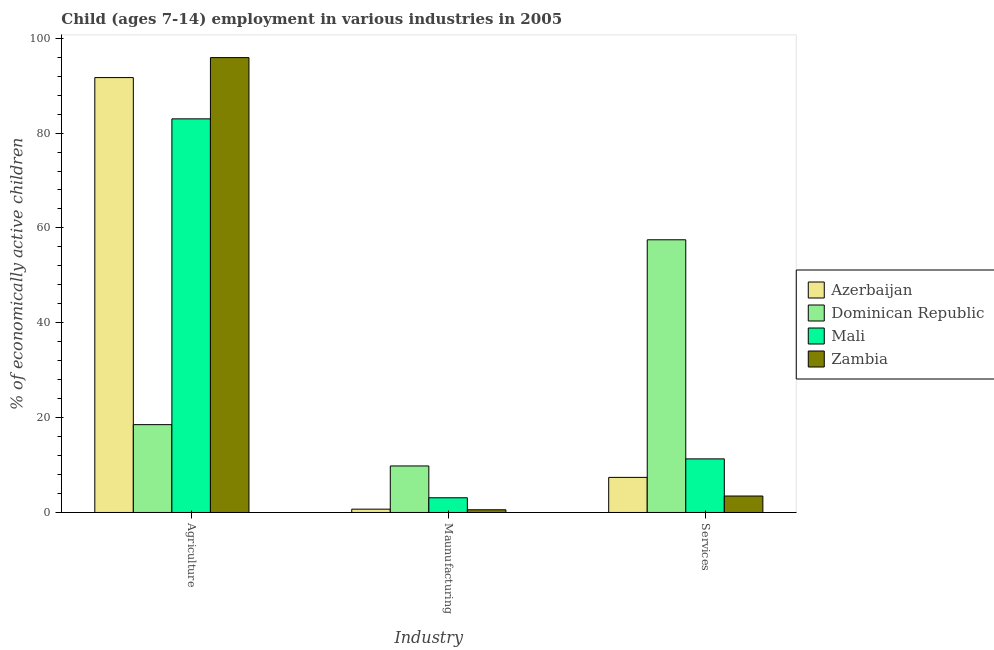How many different coloured bars are there?
Your response must be concise. 4. Are the number of bars per tick equal to the number of legend labels?
Offer a very short reply. Yes. How many bars are there on the 2nd tick from the left?
Ensure brevity in your answer.  4. What is the label of the 3rd group of bars from the left?
Provide a short and direct response. Services. What is the percentage of economically active children in manufacturing in Azerbaijan?
Offer a terse response. 0.7. Across all countries, what is the maximum percentage of economically active children in services?
Give a very brief answer. 57.5. Across all countries, what is the minimum percentage of economically active children in services?
Offer a terse response. 3.47. In which country was the percentage of economically active children in services maximum?
Offer a very short reply. Dominican Republic. In which country was the percentage of economically active children in manufacturing minimum?
Ensure brevity in your answer.  Zambia. What is the total percentage of economically active children in services in the graph?
Offer a very short reply. 79.67. What is the difference between the percentage of economically active children in agriculture in Dominican Republic and that in Zambia?
Give a very brief answer. -77.39. What is the difference between the percentage of economically active children in services in Azerbaijan and the percentage of economically active children in manufacturing in Zambia?
Ensure brevity in your answer.  6.83. What is the average percentage of economically active children in manufacturing per country?
Your response must be concise. 3.54. What is the ratio of the percentage of economically active children in services in Mali to that in Zambia?
Give a very brief answer. 3.26. Is the percentage of economically active children in manufacturing in Zambia less than that in Mali?
Offer a very short reply. Yes. What is the difference between the highest and the second highest percentage of economically active children in agriculture?
Provide a short and direct response. 4.21. What is the difference between the highest and the lowest percentage of economically active children in services?
Offer a terse response. 54.03. In how many countries, is the percentage of economically active children in services greater than the average percentage of economically active children in services taken over all countries?
Make the answer very short. 1. What does the 4th bar from the left in Services represents?
Ensure brevity in your answer.  Zambia. What does the 2nd bar from the right in Services represents?
Offer a very short reply. Mali. How many bars are there?
Provide a succinct answer. 12. Are the values on the major ticks of Y-axis written in scientific E-notation?
Give a very brief answer. No. Does the graph contain grids?
Provide a short and direct response. No. How are the legend labels stacked?
Your answer should be compact. Vertical. What is the title of the graph?
Your answer should be very brief. Child (ages 7-14) employment in various industries in 2005. Does "India" appear as one of the legend labels in the graph?
Ensure brevity in your answer.  No. What is the label or title of the X-axis?
Offer a terse response. Industry. What is the label or title of the Y-axis?
Ensure brevity in your answer.  % of economically active children. What is the % of economically active children in Azerbaijan in Agriculture?
Offer a very short reply. 91.7. What is the % of economically active children in Dominican Republic in Agriculture?
Ensure brevity in your answer.  18.52. What is the % of economically active children of Zambia in Agriculture?
Your answer should be compact. 95.91. What is the % of economically active children of Azerbaijan in Maunufacturing?
Offer a very short reply. 0.7. What is the % of economically active children of Dominican Republic in Maunufacturing?
Offer a terse response. 9.81. What is the % of economically active children in Mali in Maunufacturing?
Keep it short and to the point. 3.1. What is the % of economically active children in Zambia in Maunufacturing?
Provide a succinct answer. 0.57. What is the % of economically active children in Azerbaijan in Services?
Offer a very short reply. 7.4. What is the % of economically active children in Dominican Republic in Services?
Offer a very short reply. 57.5. What is the % of economically active children in Zambia in Services?
Provide a succinct answer. 3.47. Across all Industry, what is the maximum % of economically active children in Azerbaijan?
Give a very brief answer. 91.7. Across all Industry, what is the maximum % of economically active children in Dominican Republic?
Keep it short and to the point. 57.5. Across all Industry, what is the maximum % of economically active children of Mali?
Provide a succinct answer. 83. Across all Industry, what is the maximum % of economically active children in Zambia?
Keep it short and to the point. 95.91. Across all Industry, what is the minimum % of economically active children of Azerbaijan?
Make the answer very short. 0.7. Across all Industry, what is the minimum % of economically active children in Dominican Republic?
Provide a short and direct response. 9.81. Across all Industry, what is the minimum % of economically active children in Mali?
Keep it short and to the point. 3.1. Across all Industry, what is the minimum % of economically active children in Zambia?
Offer a very short reply. 0.57. What is the total % of economically active children in Azerbaijan in the graph?
Offer a very short reply. 99.8. What is the total % of economically active children in Dominican Republic in the graph?
Your answer should be compact. 85.83. What is the total % of economically active children of Mali in the graph?
Ensure brevity in your answer.  97.4. What is the total % of economically active children of Zambia in the graph?
Your response must be concise. 99.95. What is the difference between the % of economically active children in Azerbaijan in Agriculture and that in Maunufacturing?
Offer a very short reply. 91. What is the difference between the % of economically active children of Dominican Republic in Agriculture and that in Maunufacturing?
Ensure brevity in your answer.  8.71. What is the difference between the % of economically active children in Mali in Agriculture and that in Maunufacturing?
Your response must be concise. 79.9. What is the difference between the % of economically active children in Zambia in Agriculture and that in Maunufacturing?
Offer a terse response. 95.34. What is the difference between the % of economically active children in Azerbaijan in Agriculture and that in Services?
Offer a terse response. 84.3. What is the difference between the % of economically active children in Dominican Republic in Agriculture and that in Services?
Offer a terse response. -38.98. What is the difference between the % of economically active children of Mali in Agriculture and that in Services?
Offer a very short reply. 71.7. What is the difference between the % of economically active children of Zambia in Agriculture and that in Services?
Offer a terse response. 92.44. What is the difference between the % of economically active children in Dominican Republic in Maunufacturing and that in Services?
Give a very brief answer. -47.69. What is the difference between the % of economically active children of Mali in Maunufacturing and that in Services?
Your response must be concise. -8.2. What is the difference between the % of economically active children in Azerbaijan in Agriculture and the % of economically active children in Dominican Republic in Maunufacturing?
Offer a very short reply. 81.89. What is the difference between the % of economically active children of Azerbaijan in Agriculture and the % of economically active children of Mali in Maunufacturing?
Keep it short and to the point. 88.6. What is the difference between the % of economically active children in Azerbaijan in Agriculture and the % of economically active children in Zambia in Maunufacturing?
Provide a succinct answer. 91.13. What is the difference between the % of economically active children of Dominican Republic in Agriculture and the % of economically active children of Mali in Maunufacturing?
Provide a succinct answer. 15.42. What is the difference between the % of economically active children of Dominican Republic in Agriculture and the % of economically active children of Zambia in Maunufacturing?
Your response must be concise. 17.95. What is the difference between the % of economically active children of Mali in Agriculture and the % of economically active children of Zambia in Maunufacturing?
Your answer should be compact. 82.43. What is the difference between the % of economically active children of Azerbaijan in Agriculture and the % of economically active children of Dominican Republic in Services?
Your response must be concise. 34.2. What is the difference between the % of economically active children of Azerbaijan in Agriculture and the % of economically active children of Mali in Services?
Provide a succinct answer. 80.4. What is the difference between the % of economically active children in Azerbaijan in Agriculture and the % of economically active children in Zambia in Services?
Offer a terse response. 88.23. What is the difference between the % of economically active children in Dominican Republic in Agriculture and the % of economically active children in Mali in Services?
Offer a very short reply. 7.22. What is the difference between the % of economically active children in Dominican Republic in Agriculture and the % of economically active children in Zambia in Services?
Your answer should be compact. 15.05. What is the difference between the % of economically active children of Mali in Agriculture and the % of economically active children of Zambia in Services?
Keep it short and to the point. 79.53. What is the difference between the % of economically active children in Azerbaijan in Maunufacturing and the % of economically active children in Dominican Republic in Services?
Your answer should be compact. -56.8. What is the difference between the % of economically active children of Azerbaijan in Maunufacturing and the % of economically active children of Zambia in Services?
Your answer should be compact. -2.77. What is the difference between the % of economically active children in Dominican Republic in Maunufacturing and the % of economically active children in Mali in Services?
Provide a succinct answer. -1.49. What is the difference between the % of economically active children of Dominican Republic in Maunufacturing and the % of economically active children of Zambia in Services?
Give a very brief answer. 6.34. What is the difference between the % of economically active children in Mali in Maunufacturing and the % of economically active children in Zambia in Services?
Give a very brief answer. -0.37. What is the average % of economically active children of Azerbaijan per Industry?
Provide a succinct answer. 33.27. What is the average % of economically active children of Dominican Republic per Industry?
Give a very brief answer. 28.61. What is the average % of economically active children of Mali per Industry?
Offer a very short reply. 32.47. What is the average % of economically active children in Zambia per Industry?
Make the answer very short. 33.32. What is the difference between the % of economically active children of Azerbaijan and % of economically active children of Dominican Republic in Agriculture?
Keep it short and to the point. 73.18. What is the difference between the % of economically active children in Azerbaijan and % of economically active children in Zambia in Agriculture?
Offer a terse response. -4.21. What is the difference between the % of economically active children in Dominican Republic and % of economically active children in Mali in Agriculture?
Ensure brevity in your answer.  -64.48. What is the difference between the % of economically active children in Dominican Republic and % of economically active children in Zambia in Agriculture?
Give a very brief answer. -77.39. What is the difference between the % of economically active children in Mali and % of economically active children in Zambia in Agriculture?
Keep it short and to the point. -12.91. What is the difference between the % of economically active children in Azerbaijan and % of economically active children in Dominican Republic in Maunufacturing?
Keep it short and to the point. -9.11. What is the difference between the % of economically active children in Azerbaijan and % of economically active children in Zambia in Maunufacturing?
Keep it short and to the point. 0.13. What is the difference between the % of economically active children of Dominican Republic and % of economically active children of Mali in Maunufacturing?
Offer a terse response. 6.71. What is the difference between the % of economically active children of Dominican Republic and % of economically active children of Zambia in Maunufacturing?
Give a very brief answer. 9.24. What is the difference between the % of economically active children of Mali and % of economically active children of Zambia in Maunufacturing?
Ensure brevity in your answer.  2.53. What is the difference between the % of economically active children in Azerbaijan and % of economically active children in Dominican Republic in Services?
Offer a terse response. -50.1. What is the difference between the % of economically active children of Azerbaijan and % of economically active children of Mali in Services?
Keep it short and to the point. -3.9. What is the difference between the % of economically active children of Azerbaijan and % of economically active children of Zambia in Services?
Your response must be concise. 3.93. What is the difference between the % of economically active children of Dominican Republic and % of economically active children of Mali in Services?
Provide a succinct answer. 46.2. What is the difference between the % of economically active children of Dominican Republic and % of economically active children of Zambia in Services?
Keep it short and to the point. 54.03. What is the difference between the % of economically active children in Mali and % of economically active children in Zambia in Services?
Your answer should be compact. 7.83. What is the ratio of the % of economically active children of Azerbaijan in Agriculture to that in Maunufacturing?
Your answer should be compact. 131. What is the ratio of the % of economically active children of Dominican Republic in Agriculture to that in Maunufacturing?
Give a very brief answer. 1.89. What is the ratio of the % of economically active children in Mali in Agriculture to that in Maunufacturing?
Your answer should be compact. 26.77. What is the ratio of the % of economically active children of Zambia in Agriculture to that in Maunufacturing?
Provide a succinct answer. 168.26. What is the ratio of the % of economically active children of Azerbaijan in Agriculture to that in Services?
Offer a very short reply. 12.39. What is the ratio of the % of economically active children in Dominican Republic in Agriculture to that in Services?
Give a very brief answer. 0.32. What is the ratio of the % of economically active children in Mali in Agriculture to that in Services?
Keep it short and to the point. 7.35. What is the ratio of the % of economically active children in Zambia in Agriculture to that in Services?
Your answer should be compact. 27.64. What is the ratio of the % of economically active children of Azerbaijan in Maunufacturing to that in Services?
Your answer should be very brief. 0.09. What is the ratio of the % of economically active children of Dominican Republic in Maunufacturing to that in Services?
Offer a terse response. 0.17. What is the ratio of the % of economically active children in Mali in Maunufacturing to that in Services?
Provide a succinct answer. 0.27. What is the ratio of the % of economically active children in Zambia in Maunufacturing to that in Services?
Provide a succinct answer. 0.16. What is the difference between the highest and the second highest % of economically active children in Azerbaijan?
Make the answer very short. 84.3. What is the difference between the highest and the second highest % of economically active children of Dominican Republic?
Keep it short and to the point. 38.98. What is the difference between the highest and the second highest % of economically active children of Mali?
Offer a terse response. 71.7. What is the difference between the highest and the second highest % of economically active children in Zambia?
Your answer should be compact. 92.44. What is the difference between the highest and the lowest % of economically active children in Azerbaijan?
Keep it short and to the point. 91. What is the difference between the highest and the lowest % of economically active children in Dominican Republic?
Keep it short and to the point. 47.69. What is the difference between the highest and the lowest % of economically active children in Mali?
Provide a short and direct response. 79.9. What is the difference between the highest and the lowest % of economically active children of Zambia?
Offer a terse response. 95.34. 